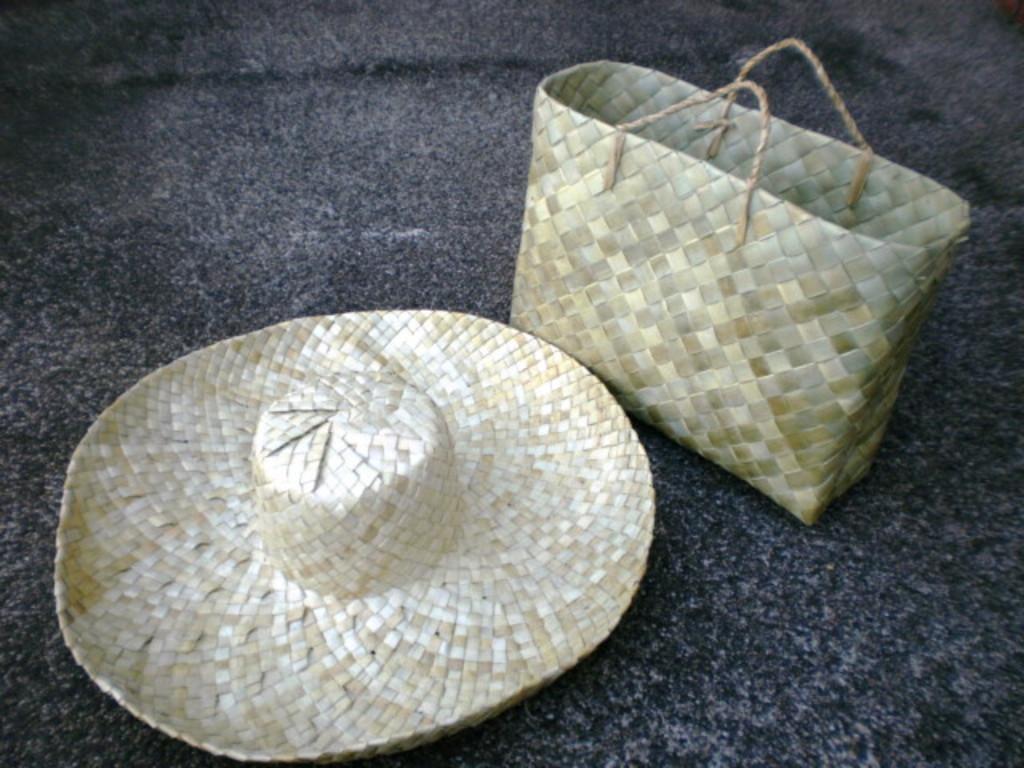In one or two sentences, can you explain what this image depicts? In this picture there is a hat and a basket on the ground. Both of them are made up of dried leaves. 